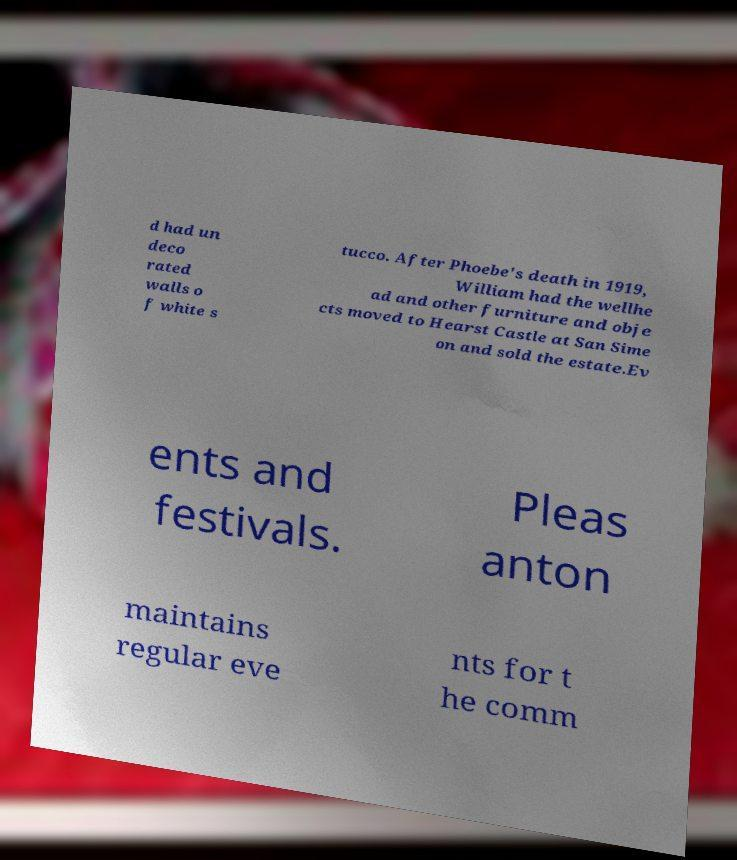Can you read and provide the text displayed in the image?This photo seems to have some interesting text. Can you extract and type it out for me? d had un deco rated walls o f white s tucco. After Phoebe's death in 1919, William had the wellhe ad and other furniture and obje cts moved to Hearst Castle at San Sime on and sold the estate.Ev ents and festivals. Pleas anton maintains regular eve nts for t he comm 